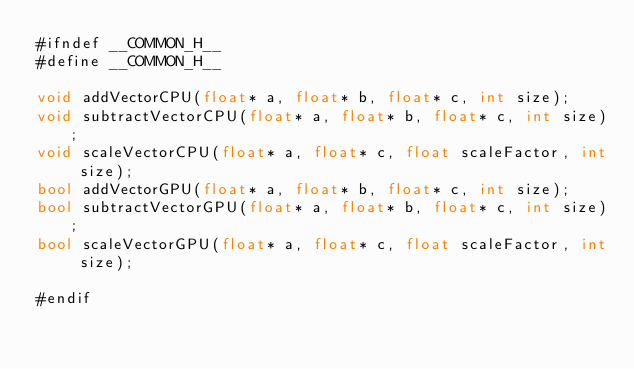Convert code to text. <code><loc_0><loc_0><loc_500><loc_500><_Cuda_>#ifndef __COMMON_H__
#define __COMMON_H__

void addVectorCPU(float* a, float* b, float* c, int size);
void subtractVectorCPU(float* a, float* b, float* c, int size);
void scaleVectorCPU(float* a, float* c, float scaleFactor, int size);
bool addVectorGPU(float* a, float* b, float* c, int size);
bool subtractVectorGPU(float* a, float* b, float* c, int size);
bool scaleVectorGPU(float* a, float* c, float scaleFactor, int size);

#endif</code> 